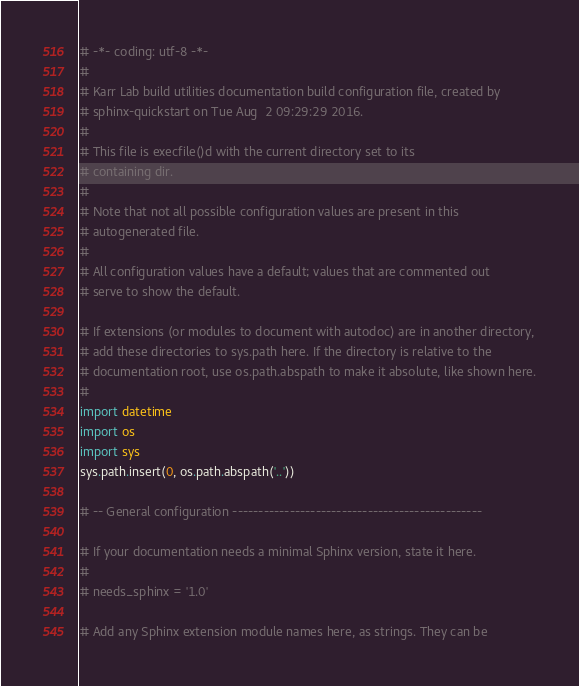Convert code to text. <code><loc_0><loc_0><loc_500><loc_500><_Python_># -*- coding: utf-8 -*-
#
# Karr Lab build utilities documentation build configuration file, created by
# sphinx-quickstart on Tue Aug  2 09:29:29 2016.
#
# This file is execfile()d with the current directory set to its
# containing dir.
#
# Note that not all possible configuration values are present in this
# autogenerated file.
#
# All configuration values have a default; values that are commented out
# serve to show the default.

# If extensions (or modules to document with autodoc) are in another directory,
# add these directories to sys.path here. If the directory is relative to the
# documentation root, use os.path.abspath to make it absolute, like shown here.
#
import datetime
import os
import sys
sys.path.insert(0, os.path.abspath('..'))

# -- General configuration ------------------------------------------------

# If your documentation needs a minimal Sphinx version, state it here.
#
# needs_sphinx = '1.0'

# Add any Sphinx extension module names here, as strings. They can be</code> 